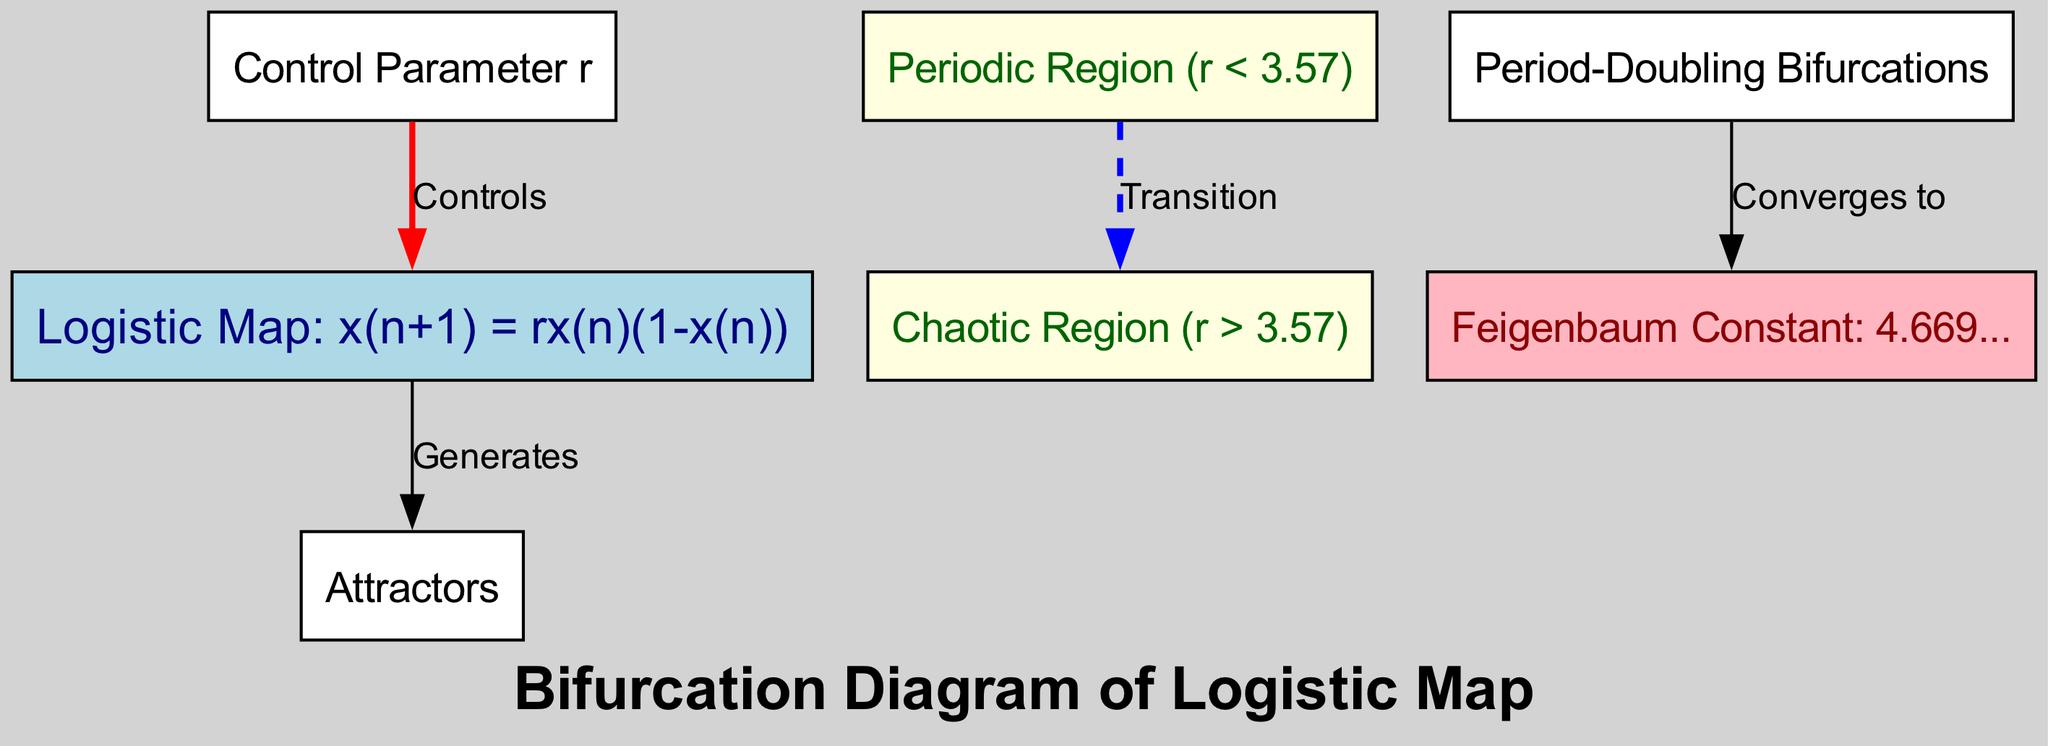What does the logistic map represent? The logistic map is represented by the equation x(n+1) = rx(n)(1-x(n)), which describes how a population evolves over time based on its growth rate (r) and current population size (x(n)). This defines the system being studied in the diagram.
Answer: Logistic Map: x(n+1) = rx(n)(1-x(n)) What is the control parameter in this diagram? The control parameter is represented in the diagram as 'r', which affects the behavior of the logistic map and the resulting dynamics. It determines whether the motion is periodic or chaotic.
Answer: Control Parameter r What is the critical value of r that separates the periodic and chaotic regions? The critical value at which the transition from periodic to chaotic motion occurs is marked at r = 3.57 in the diagram. This is an important threshold in the study of dynamical systems.
Answer: 3.57 How many distinct regions are shown in the diagram? The diagram identifies two distinct regions: the periodic region and the chaotic region, which are separated by a transition represented in the diagram.
Answer: 2 What process leads to the emergence of chaos in this diagram? The emergence of chaos is indicated through the 'Period-Doubling Bifurcations', which sequentially doubles the period of motion until chaos arises. This highlights the route to chaos in dynamical systems.
Answer: Period-Doubling Bifurcations What constant is associated with the period-doubling bifurcation in this diagram? The 'Feigenbaum Constant' is associated with the period-doubling bifurcation, which is approximately 4.669. It reflects the scaling factor in the bifurcation process.
Answer: Feigenbaum Constant: 4.669.. Which region is indicated to contain attractors in the diagram? The diagram clearly indicates that attractors are generated by the logistic map itself, which is a key feature in the study of dynamical systems and their long-term behavior.
Answer: Attractors What style is used for the edge connecting the periodic region to the chaotic region? The edge connecting the periodic to the chaotic region utilizes a dashed style, highlighting the transition between the two states as more complex dynamics take over.
Answer: Dashed Which color represents the chaotic region in the diagram? The chaotic region is represented by a light yellow color, visually distinguishing it from the periodic region and other components within the diagram.
Answer: Light yellow 